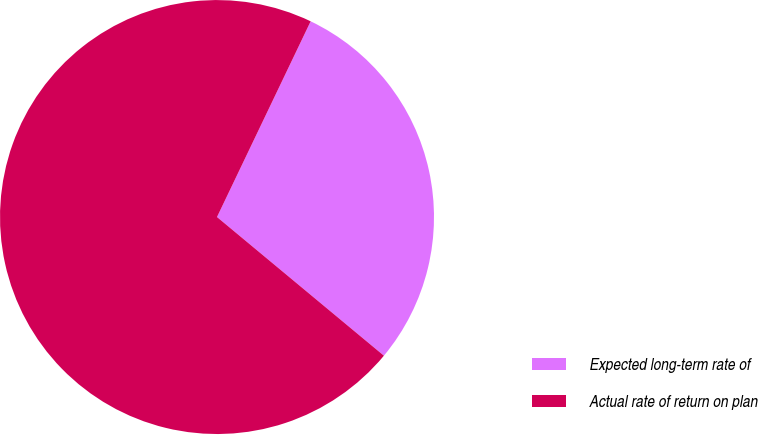Convert chart to OTSL. <chart><loc_0><loc_0><loc_500><loc_500><pie_chart><fcel>Expected long-term rate of<fcel>Actual rate of return on plan<nl><fcel>28.93%<fcel>71.07%<nl></chart> 